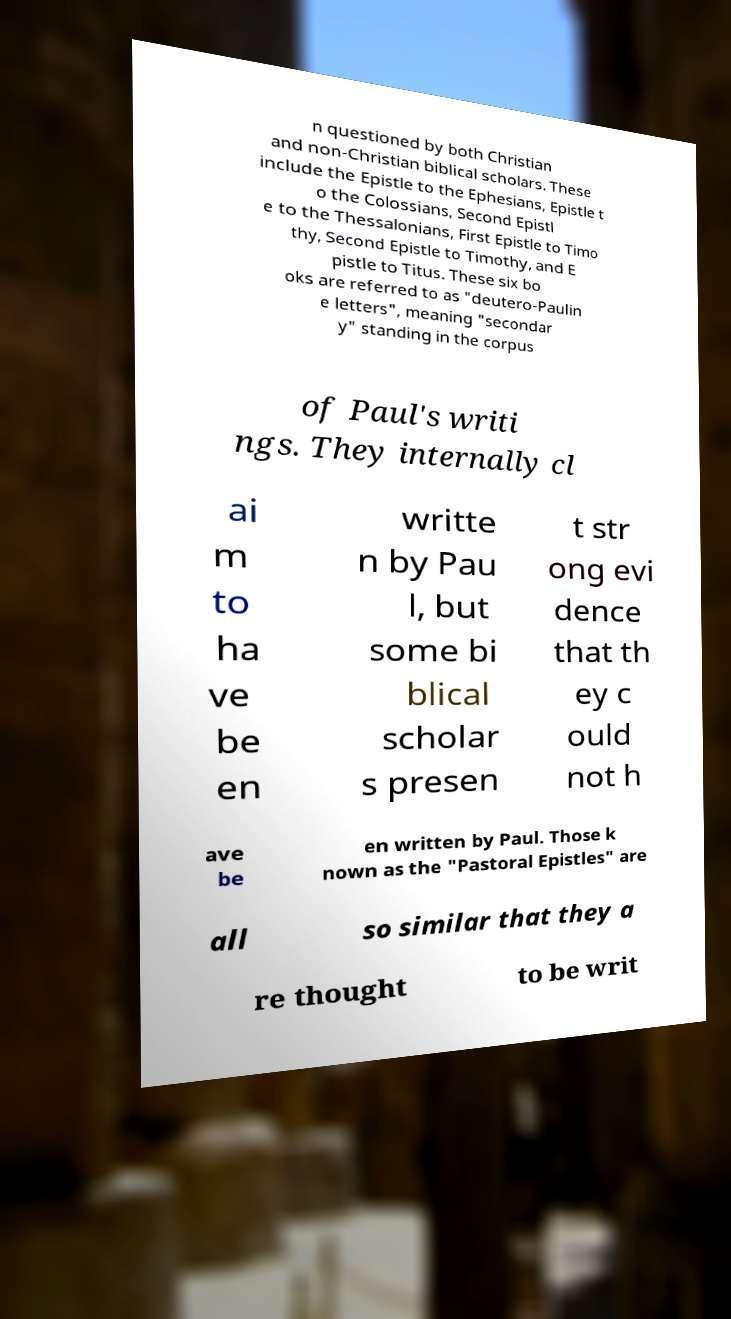Can you read and provide the text displayed in the image?This photo seems to have some interesting text. Can you extract and type it out for me? n questioned by both Christian and non-Christian biblical scholars. These include the Epistle to the Ephesians, Epistle t o the Colossians, Second Epistl e to the Thessalonians, First Epistle to Timo thy, Second Epistle to Timothy, and E pistle to Titus. These six bo oks are referred to as "deutero-Paulin e letters", meaning "secondar y" standing in the corpus of Paul's writi ngs. They internally cl ai m to ha ve be en writte n by Pau l, but some bi blical scholar s presen t str ong evi dence that th ey c ould not h ave be en written by Paul. Those k nown as the "Pastoral Epistles" are all so similar that they a re thought to be writ 